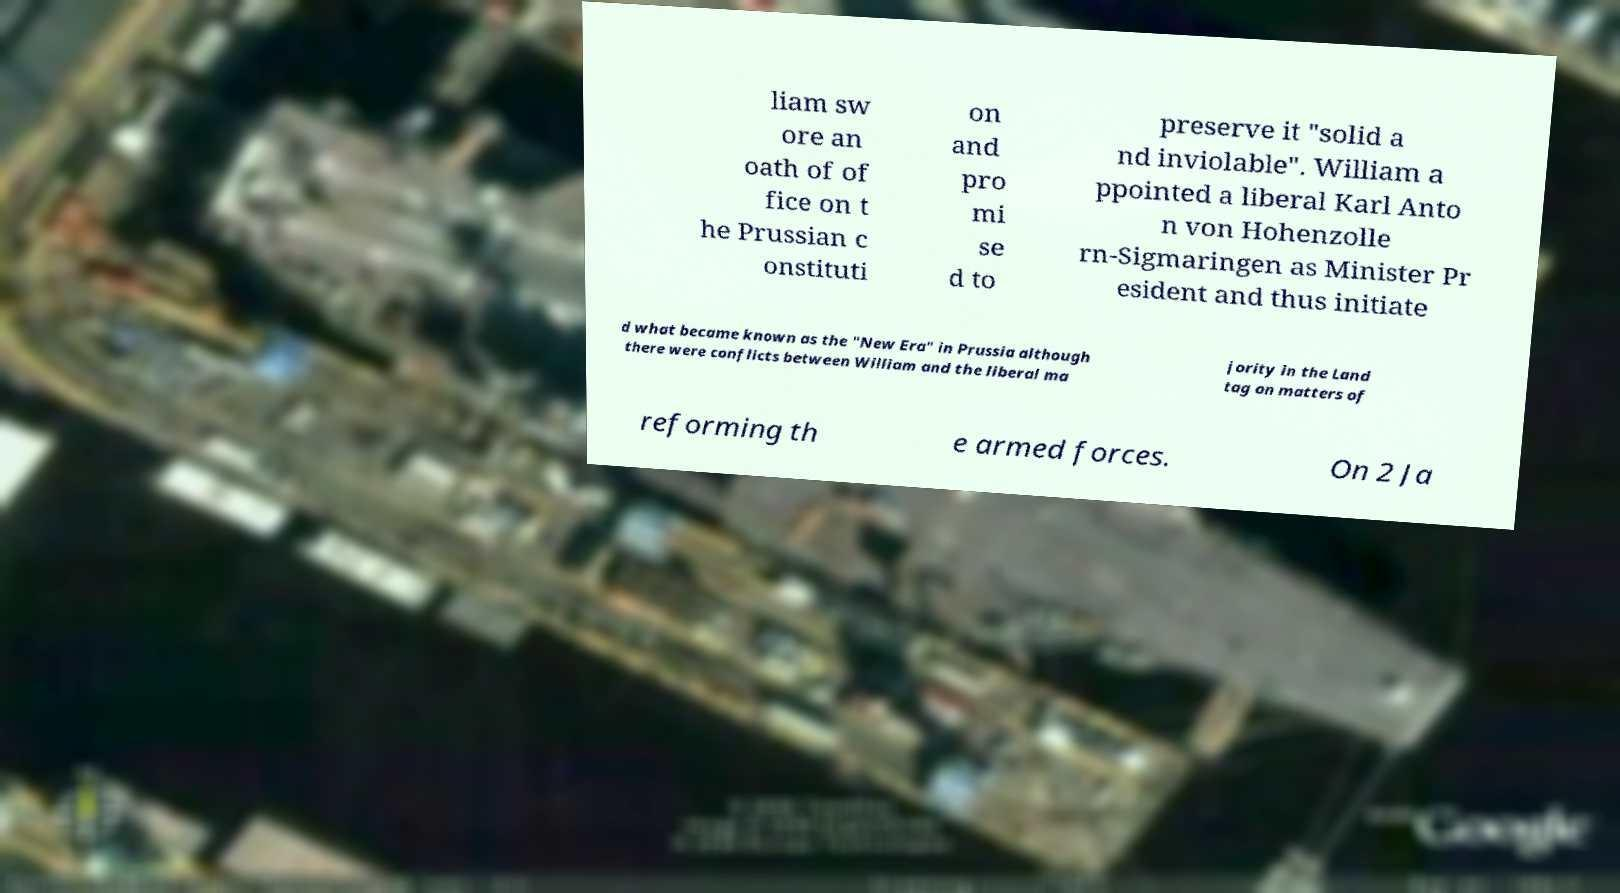Please identify and transcribe the text found in this image. liam sw ore an oath of of fice on t he Prussian c onstituti on and pro mi se d to preserve it "solid a nd inviolable". William a ppointed a liberal Karl Anto n von Hohenzolle rn-Sigmaringen as Minister Pr esident and thus initiate d what became known as the "New Era" in Prussia although there were conflicts between William and the liberal ma jority in the Land tag on matters of reforming th e armed forces. On 2 Ja 